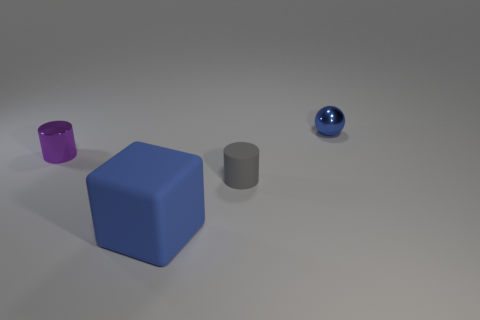Subtract all gray cylinders. How many cylinders are left? 1 Add 1 large rubber balls. How many objects exist? 5 Subtract 2 cylinders. How many cylinders are left? 0 Subtract all spheres. How many objects are left? 3 Subtract all green cylinders. Subtract all purple balls. How many cylinders are left? 2 Subtract all red blocks. How many brown cylinders are left? 0 Subtract all tiny gray matte cylinders. Subtract all purple shiny cylinders. How many objects are left? 2 Add 2 tiny metal spheres. How many tiny metal spheres are left? 3 Add 4 shiny spheres. How many shiny spheres exist? 5 Subtract 0 green balls. How many objects are left? 4 